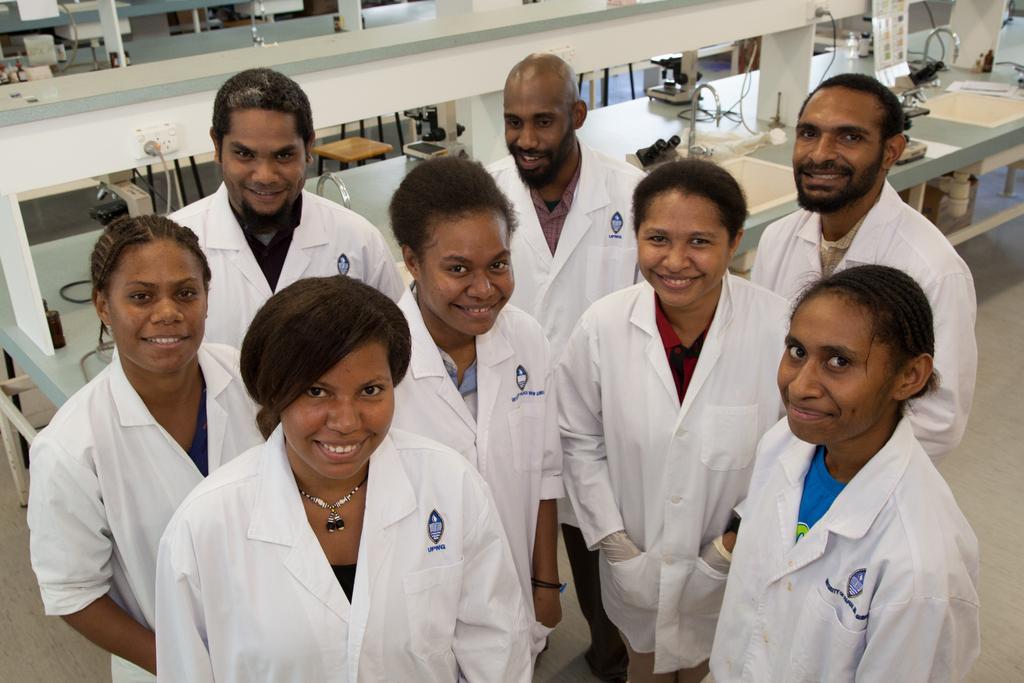In one or two sentences, can you explain what this image depicts? This is the picture of a place where we have some people wearing white aprons and behind there are some desk on which there are some things placed. 